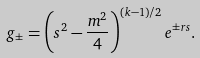<formula> <loc_0><loc_0><loc_500><loc_500>g _ { \pm } = \left ( s ^ { 2 } - \frac { m ^ { 2 } } { 4 } \right ) ^ { ( k - 1 ) / 2 } e ^ { \pm r s } .</formula> 